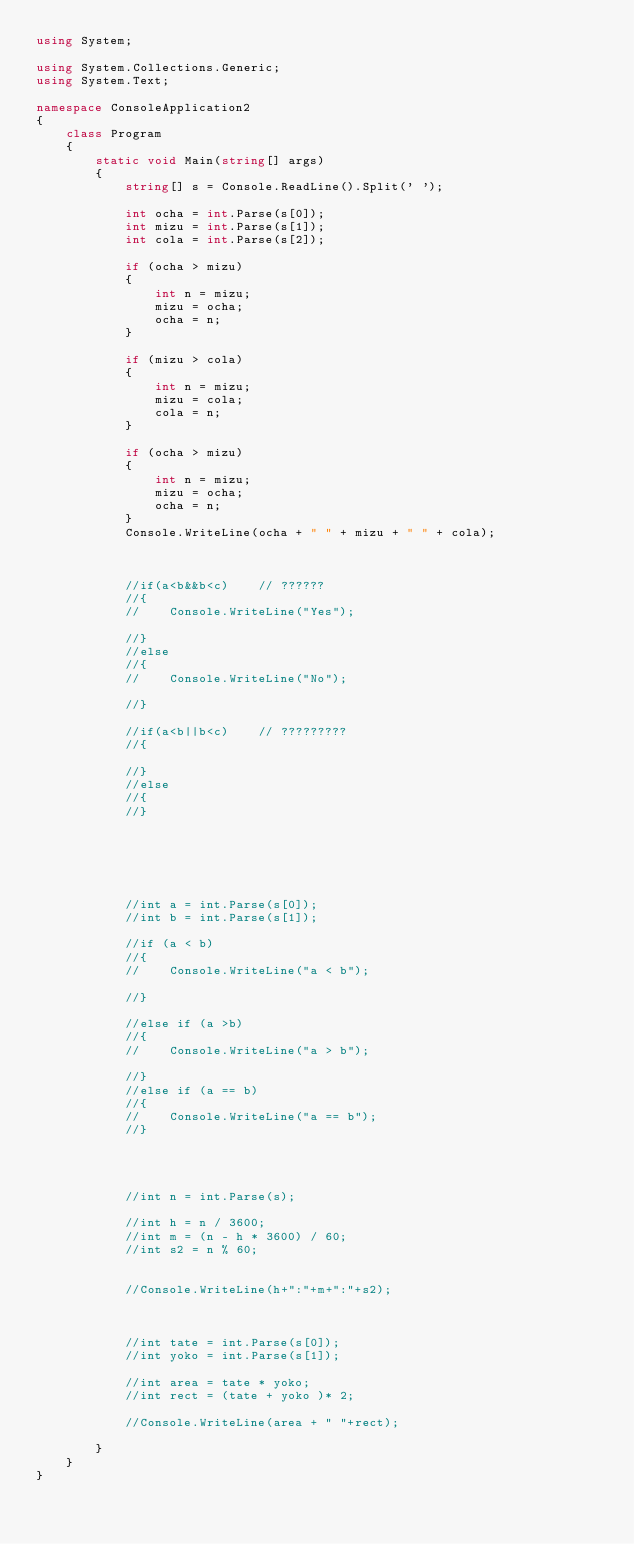Convert code to text. <code><loc_0><loc_0><loc_500><loc_500><_C#_>using System;

using System.Collections.Generic;
using System.Text;

namespace ConsoleApplication2
{
    class Program
    {
        static void Main(string[] args)
        {
            string[] s = Console.ReadLine().Split(' ');

            int ocha = int.Parse(s[0]);
            int mizu = int.Parse(s[1]);
            int cola = int.Parse(s[2]);

            if (ocha > mizu)
            {
                int n = mizu;
                mizu = ocha;
                ocha = n;
            }

            if (mizu > cola)
            {
                int n = mizu;
                mizu = cola;
                cola = n;
            }

            if (ocha > mizu)
            {
                int n = mizu;
                mizu = ocha;
                ocha = n;
            }
            Console.WriteLine(ocha + " " + mizu + " " + cola);



            //if(a<b&&b<c)    // ??????
            //{
            //    Console.WriteLine("Yes");

            //}
            //else
            //{
            //    Console.WriteLine("No");

            //}

            //if(a<b||b<c)    // ?????????
            //{

            //}
            //else
            //{ 
            //}






            //int a = int.Parse(s[0]);
            //int b = int.Parse(s[1]);

            //if (a < b)
            //{
            //    Console.WriteLine("a < b");

            //}

            //else if (a >b)
            //{
            //    Console.WriteLine("a > b");

            //}
            //else if (a == b)
            //{
            //    Console.WriteLine("a == b");
            //}




            //int n = int.Parse(s);

            //int h = n / 3600;
            //int m = (n - h * 3600) / 60;
            //int s2 = n % 60;


            //Console.WriteLine(h+":"+m+":"+s2);



            //int tate = int.Parse(s[0]);
            //int yoko = int.Parse(s[1]);

            //int area = tate * yoko;
            //int rect = (tate + yoko )* 2;

            //Console.WriteLine(area + " "+rect);

        }
    }
}</code> 